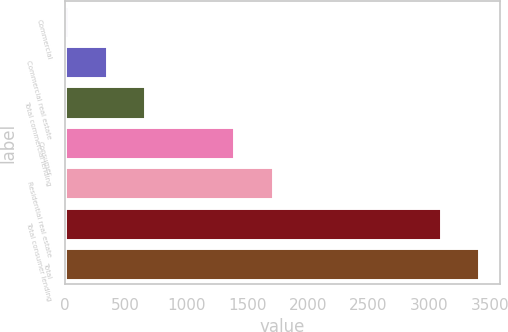<chart> <loc_0><loc_0><loc_500><loc_500><bar_chart><fcel>Commercial<fcel>Commercial real estate<fcel>Total commercial lending<fcel>Consumer<fcel>Residential real estate<fcel>Total consumer lending<fcel>Total<nl><fcel>24<fcel>342.8<fcel>661.6<fcel>1392<fcel>1710.8<fcel>3092<fcel>3410.8<nl></chart> 